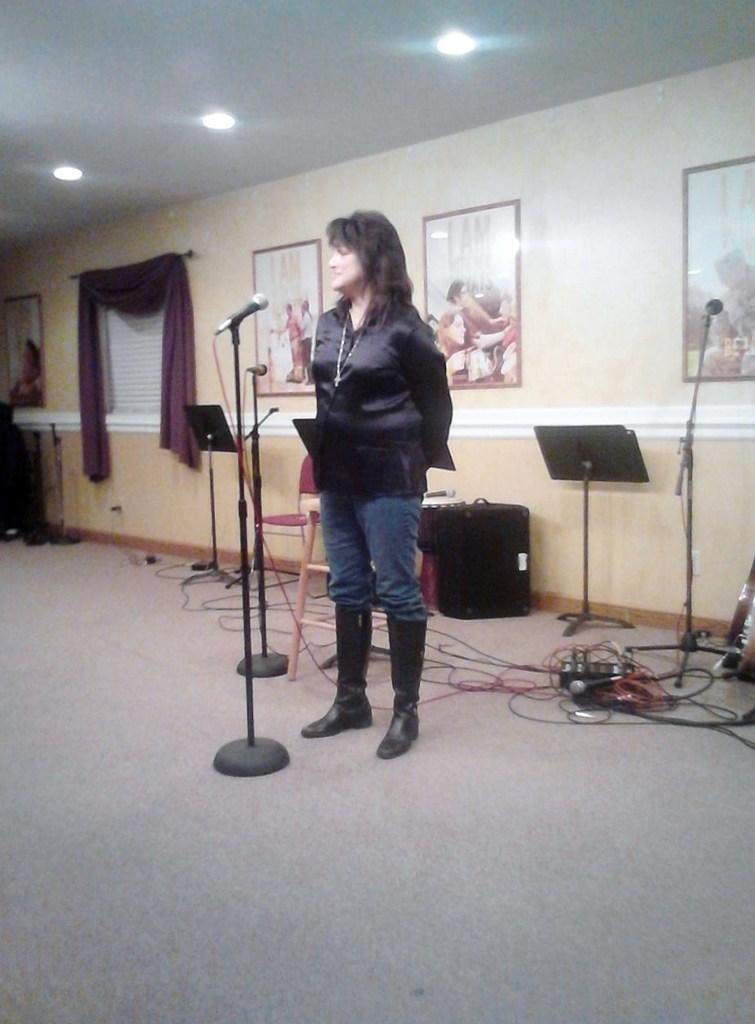Who is the main subject in the image? There is a woman in the image. What is the woman doing in the image? The woman is standing and speaking into a microphone. What can be seen on the wall behind the woman? There are photographs on a wall behind the woman. What type of reward is the woman holding in the image? There is no reward visible in the image; the woman is speaking into a microphone and standing in front of photographs on a wall. 